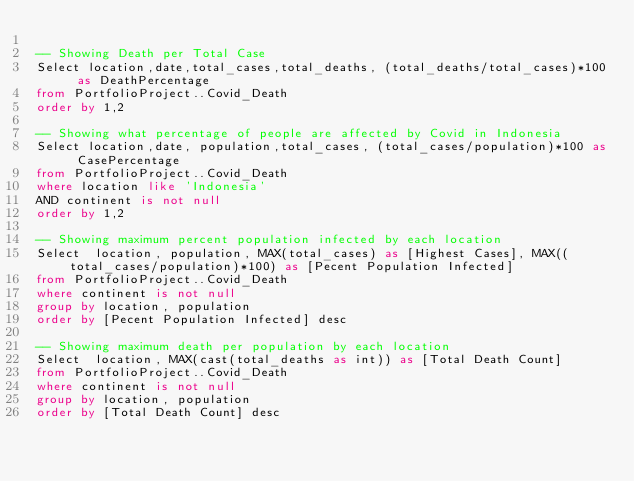Convert code to text. <code><loc_0><loc_0><loc_500><loc_500><_SQL_>
-- Showing Death per Total Case
Select location,date,total_cases,total_deaths, (total_deaths/total_cases)*100 as DeathPercentage
from PortfolioProject..Covid_Death
order by 1,2 

-- Showing what percentage of people are affected by Covid in Indonesia
Select location,date, population,total_cases, (total_cases/population)*100 as CasePercentage
from PortfolioProject..Covid_Death
where location like 'Indonesia'
AND continent is not null
order by 1,2 

-- Showing maximum percent population infected by each location 
Select  location, population, MAX(total_cases) as [Highest Cases], MAX((total_cases/population)*100) as [Pecent Population Infected]
from PortfolioProject..Covid_Death
where continent is not null
group by location, population
order by [Pecent Population Infected] desc

-- Showing maximum death per population by each location
Select  location, MAX(cast(total_deaths as int)) as [Total Death Count]
from PortfolioProject..Covid_Death
where continent is not null
group by location, population
order by [Total Death Count] desc
</code> 